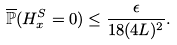<formula> <loc_0><loc_0><loc_500><loc_500>\overline { \mathbb { P } } ( H ^ { S } _ { x } = 0 ) \leq \frac { \epsilon } { 1 8 ( 4 L ) ^ { 2 } } .</formula> 